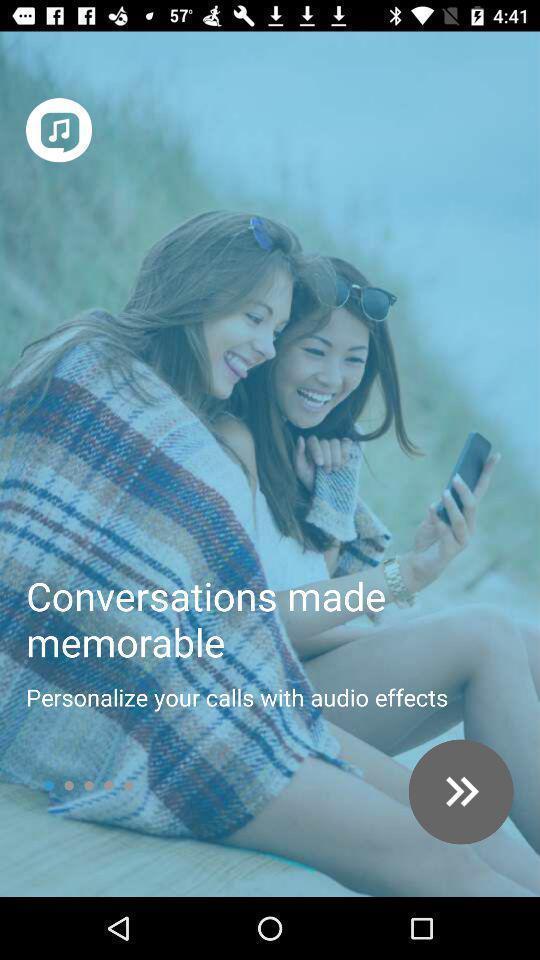What details can you identify in this image? Welcome page of calls and messaging app. 